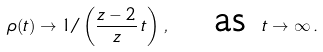<formula> <loc_0><loc_0><loc_500><loc_500>\rho ( t ) \to 1 / \left ( \frac { z - 2 } { z } \, t \right ) \, , \quad \text {as\ } t \to \infty \, .</formula> 